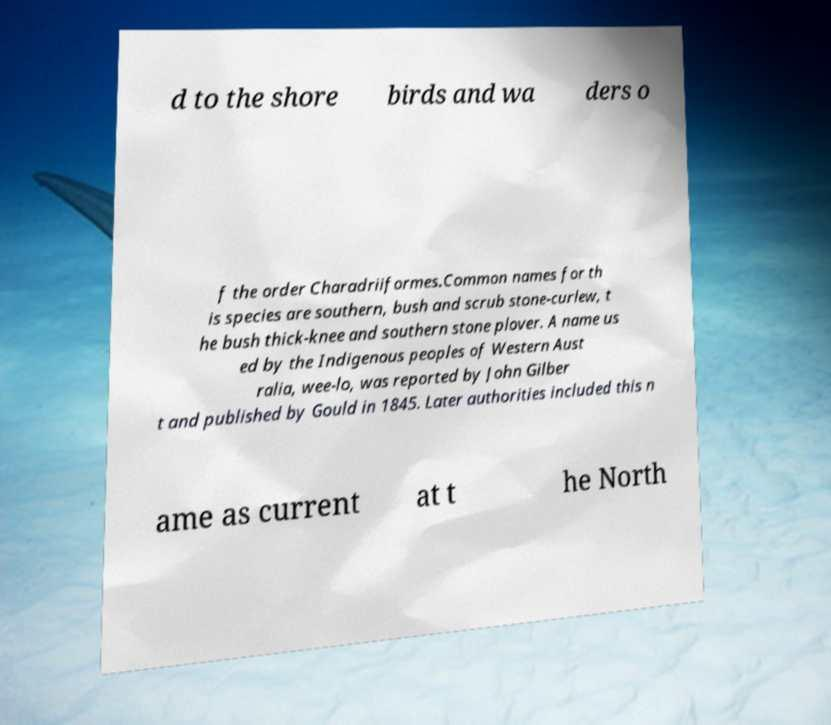Could you extract and type out the text from this image? d to the shore birds and wa ders o f the order Charadriiformes.Common names for th is species are southern, bush and scrub stone-curlew, t he bush thick-knee and southern stone plover. A name us ed by the Indigenous peoples of Western Aust ralia, wee-lo, was reported by John Gilber t and published by Gould in 1845. Later authorities included this n ame as current at t he North 